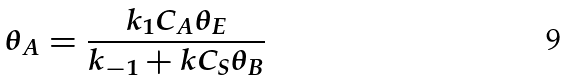Convert formula to latex. <formula><loc_0><loc_0><loc_500><loc_500>\theta _ { A } = \frac { k _ { 1 } C _ { A } \theta _ { E } } { k _ { - 1 } + k C _ { S } \theta _ { B } }</formula> 